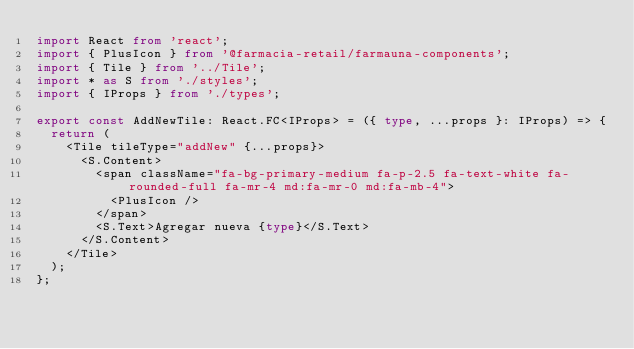Convert code to text. <code><loc_0><loc_0><loc_500><loc_500><_TypeScript_>import React from 'react';
import { PlusIcon } from '@farmacia-retail/farmauna-components';
import { Tile } from '../Tile';
import * as S from './styles';
import { IProps } from './types';

export const AddNewTile: React.FC<IProps> = ({ type, ...props }: IProps) => {
  return (
    <Tile tileType="addNew" {...props}>
      <S.Content>
        <span className="fa-bg-primary-medium fa-p-2.5 fa-text-white fa-rounded-full fa-mr-4 md:fa-mr-0 md:fa-mb-4">
          <PlusIcon />
        </span>
        <S.Text>Agregar nueva {type}</S.Text>
      </S.Content>
    </Tile>
  );
};
</code> 